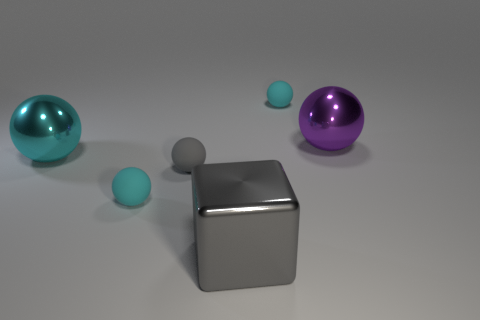Subtract all blue cylinders. How many cyan balls are left? 3 Subtract 1 spheres. How many spheres are left? 4 Subtract all gray spheres. How many spheres are left? 4 Subtract all cyan metallic balls. How many balls are left? 4 Subtract all brown balls. Subtract all brown cubes. How many balls are left? 5 Add 3 gray blocks. How many objects exist? 9 Subtract all blocks. How many objects are left? 5 Add 5 large red metal spheres. How many large red metal spheres exist? 5 Subtract 3 cyan spheres. How many objects are left? 3 Subtract all gray things. Subtract all small red cubes. How many objects are left? 4 